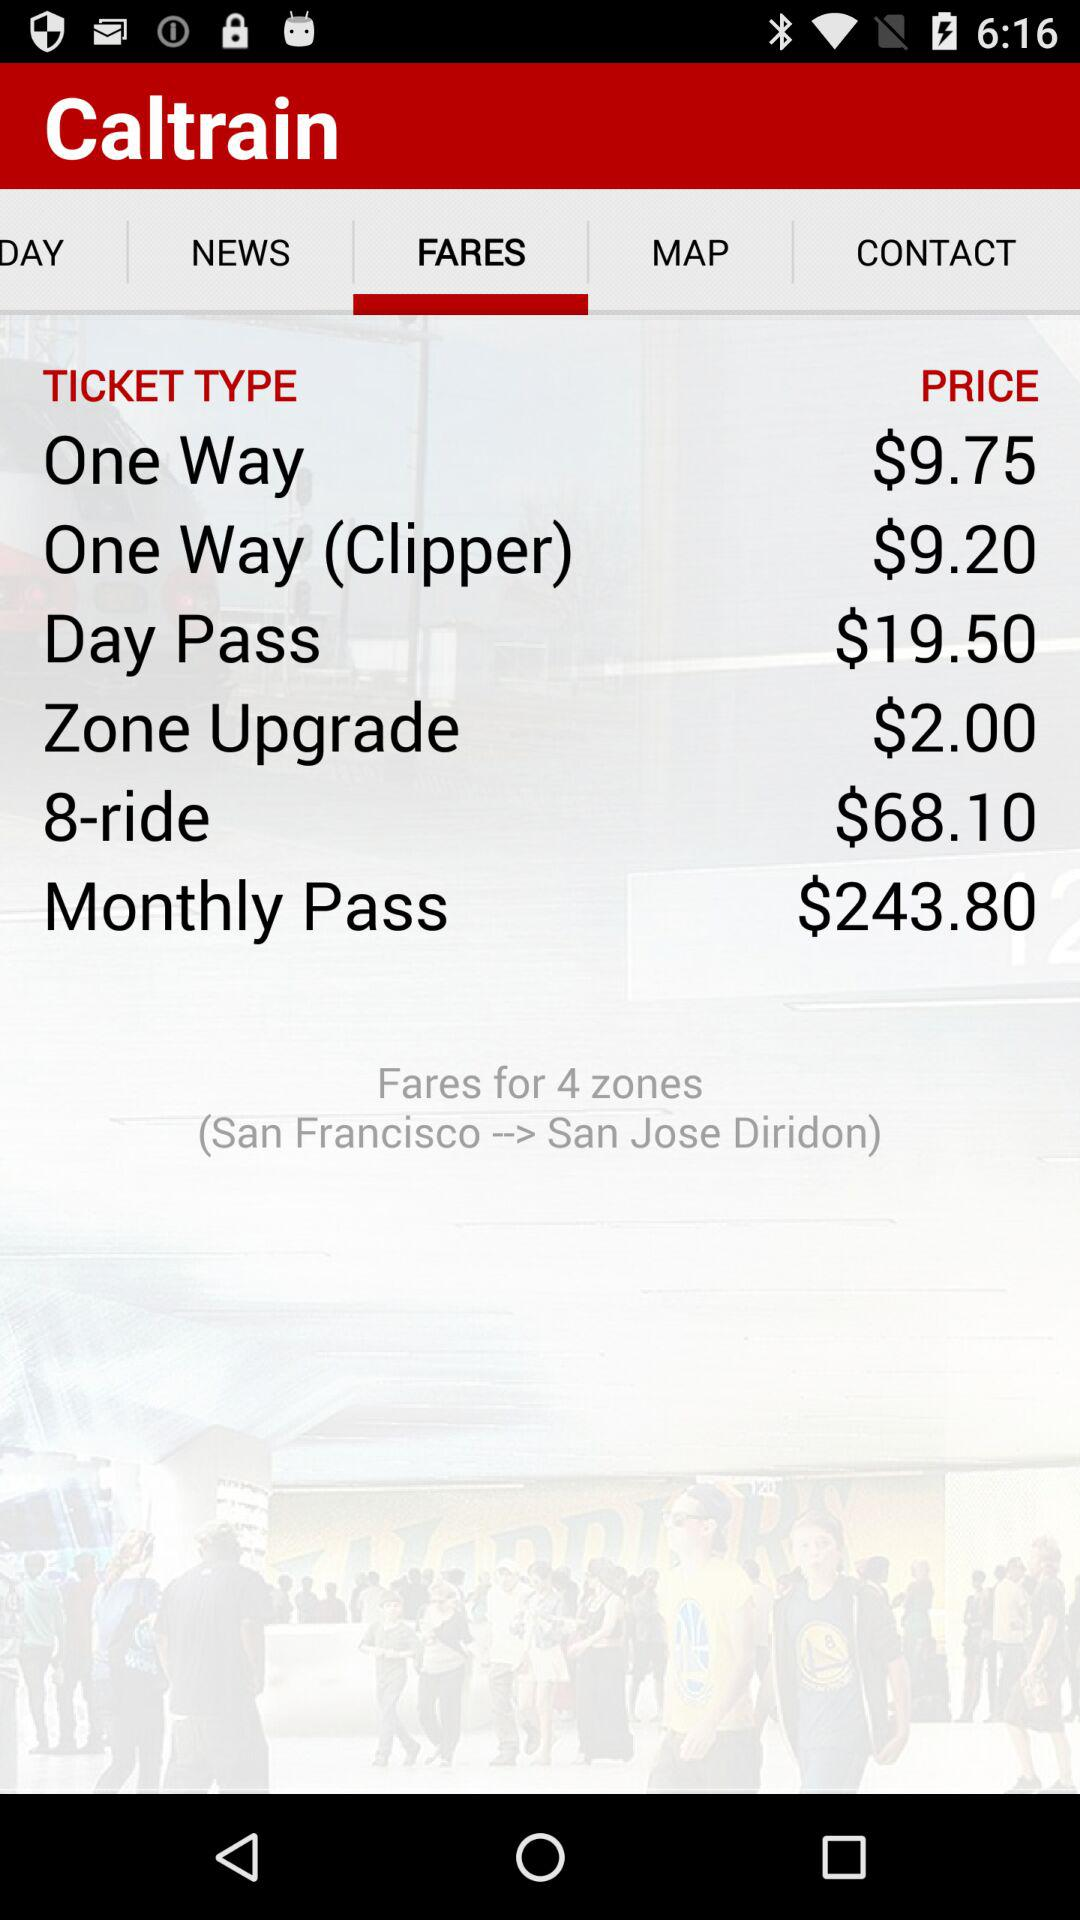What is the count of zones? The count of zones is 4. 